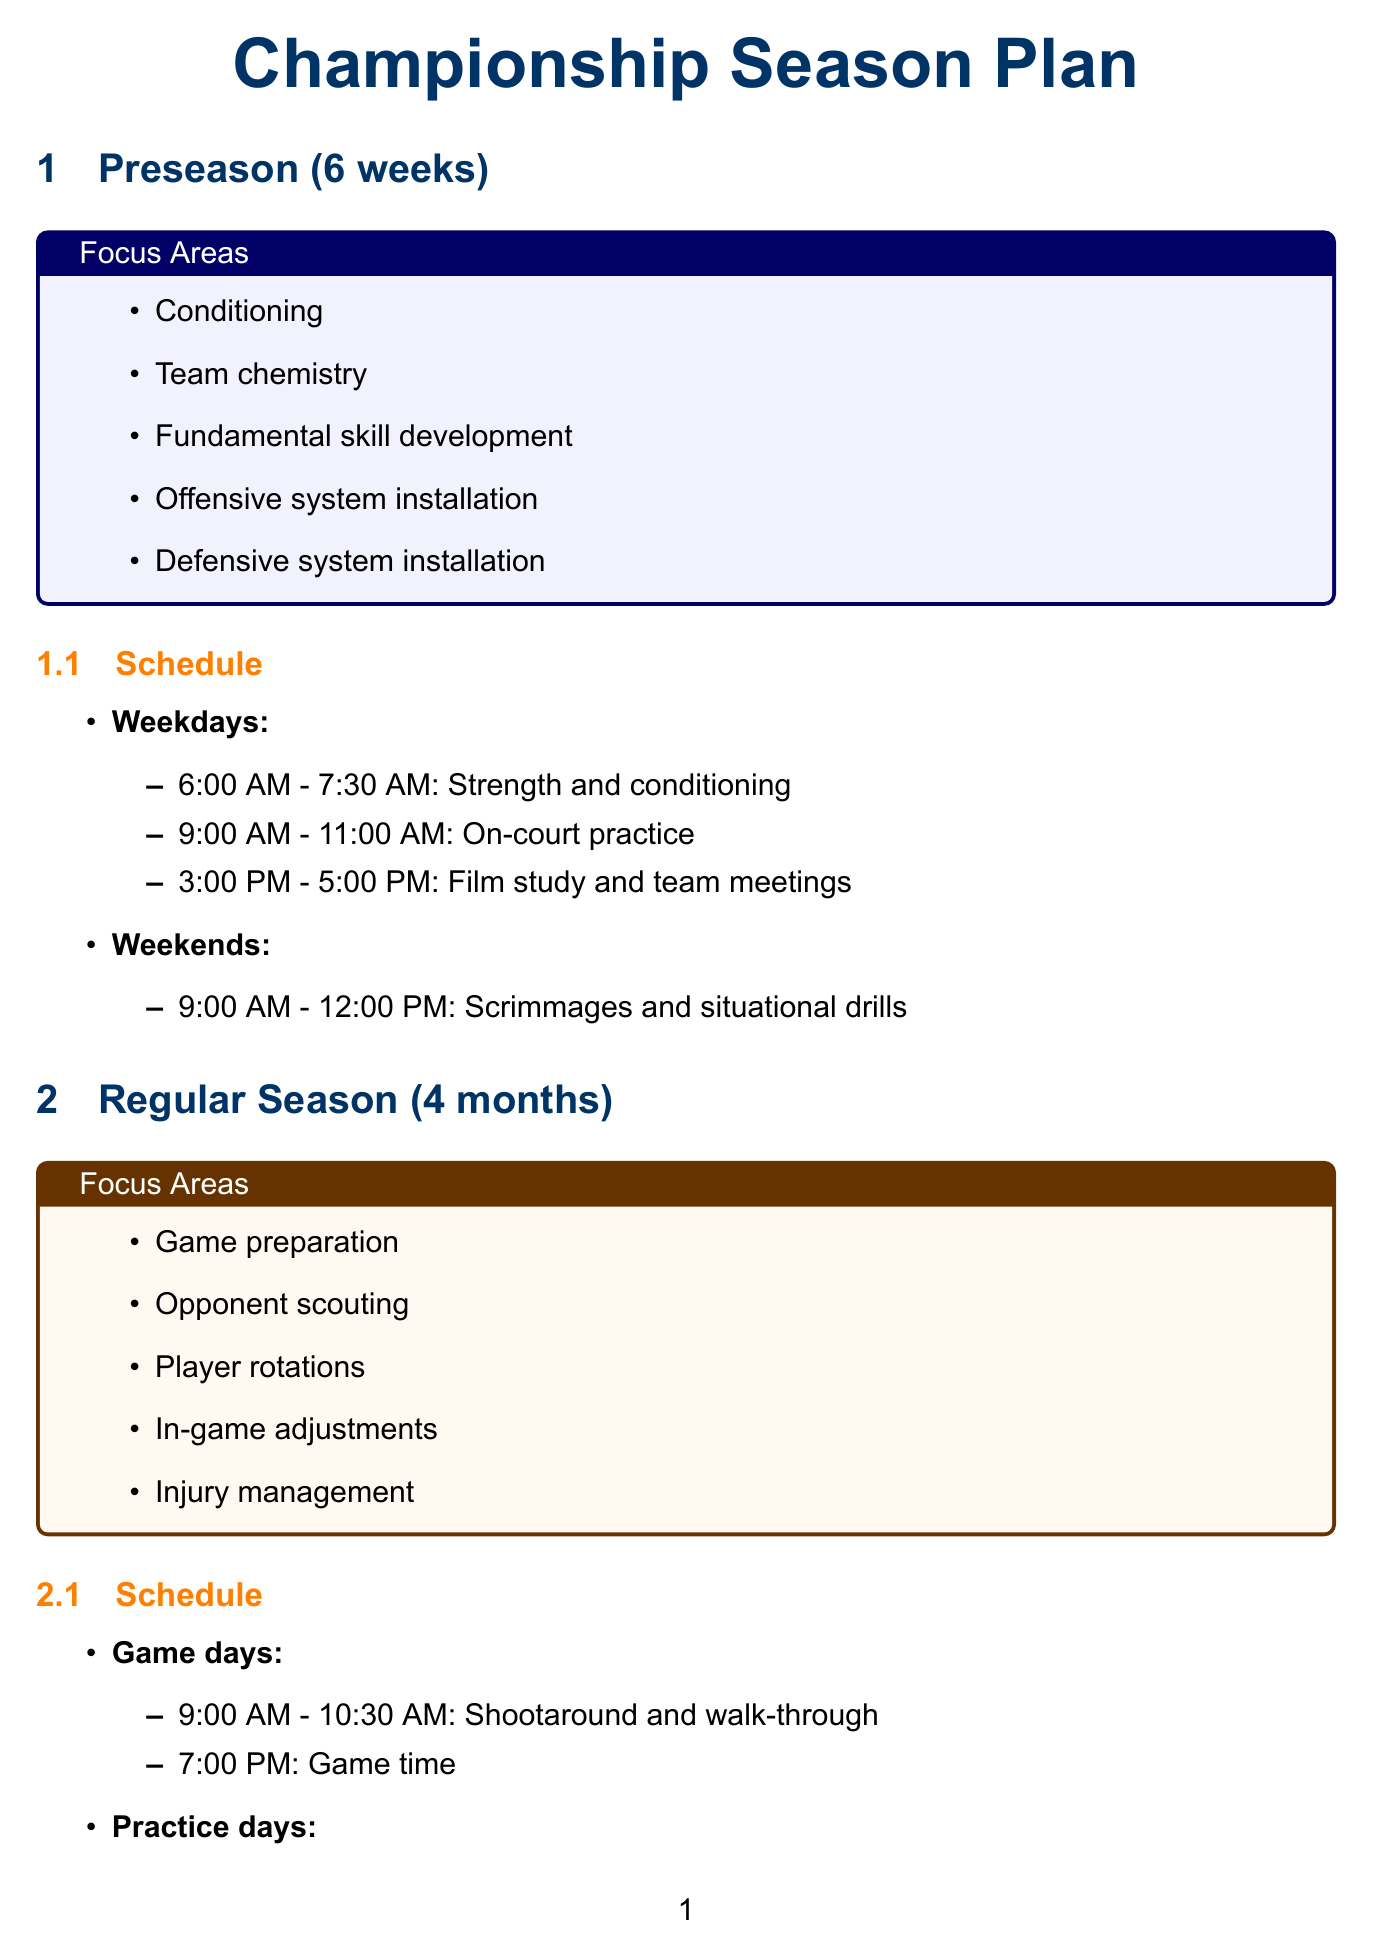What is the duration of the preseason? The duration of the preseason is stated explicitly in the document as 6 weeks.
Answer: 6 weeks What is the focus area for player rotations? The reasoning involves identifying the focus areas during the regular season, where "Player rotations" is explicitly listed as one of the focus areas.
Answer: Player rotations At what time does practice start on game days? The specific timing for the activity "Shootaround and walk-through" on game days is provided, indicating it begins at 9:00 AM.
Answer: 9:00 AM How long is the Villanova Shell Drill? The duration of the Villanova Shell Drill is clearly mentioned, which is 25 minutes.
Answer: 25 minutes What are the key performance indicators listed in the document? The question encompasses identifying multiple performance metrics mentioned, which are listed in an itemized format.
Answer: Field goal percentage, three-point percentage, free throw percentage, rebounds per game, assists to turnover ratio, points allowed per possession, steals and blocks per game What is the schedule for injury prevention activities? The schedule for injury prevention is explicitly stated to be 20 minutes before and after each practice session.
Answer: 20 minutes before and after each practice session Which specific drill focuses on team defense and rotations? Reasoning involves matching the drill name with its focus area, where the "Villanova Shell Drill" is indicated to emphasize team defense and rotations.
Answer: Villanova Shell Drill What activity occurs at 3:00 PM on weekdays during preseason? The scheduled activity at this time during the preseason is detailed in the document under weekdays, explicitly stating "Film study and team meetings."
Answer: Film study and team meetings 